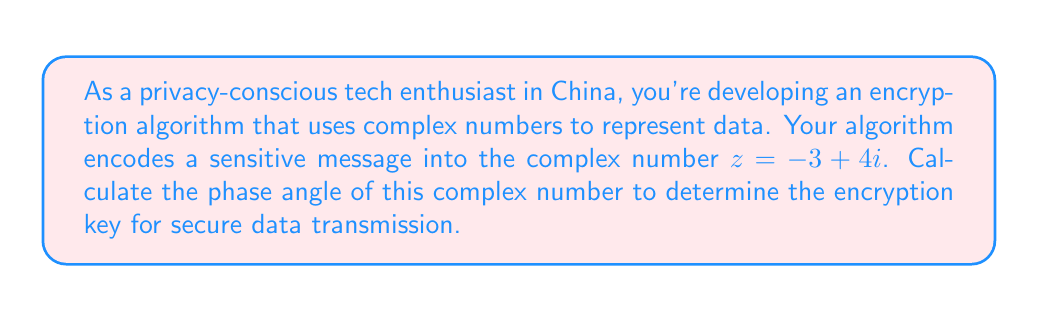Can you solve this math problem? To calculate the phase angle of a complex number, we use the arctangent function. The phase angle, also known as the argument, is denoted as $\arg(z)$ or $\theta$.

For a complex number $z = a + bi$, the phase angle is given by:

$$\theta = \arctan\left(\frac{b}{a}\right)$$

However, we need to be careful about which quadrant the complex number lies in. For our case, $z = -3 + 4i$, we have:

$a = -3$ (real part)
$b = 4$ (imaginary part)

Since $a$ is negative and $b$ is positive, our complex number lies in the second quadrant. For numbers in the second quadrant, we need to add $\pi$ to the result of arctangent.

Let's calculate:

$$\theta = \arctan\left(\frac{4}{-3}\right) + \pi$$

$$\theta = \arctan(-1.3333...) + \pi$$

$$\theta \approx -0.9272 + \pi$$

$$\theta \approx 2.2143 \text{ radians}$$

To convert to degrees, multiply by $\frac{180}{\pi}$:

$$\theta \approx 2.2143 \cdot \frac{180}{\pi} \approx 126.87°$$

[asy]
import geometry;

size(200);
draw((-3,0)--(3,0),Arrow);
draw((0,-3)--(0,4),Arrow);
dot((-3,4));
draw((0,0)--(-3,4),Arrow);
label("$z = -3 + 4i$", (-3,4), NE);
draw(arc((0,0),1,0,126.87), Arrow);
label("$\theta$", (0.5,0.5), NE);
[/asy]
Answer: The phase angle of the complex number $z = -3 + 4i$ is approximately $2.2143$ radians or $126.87°$. 